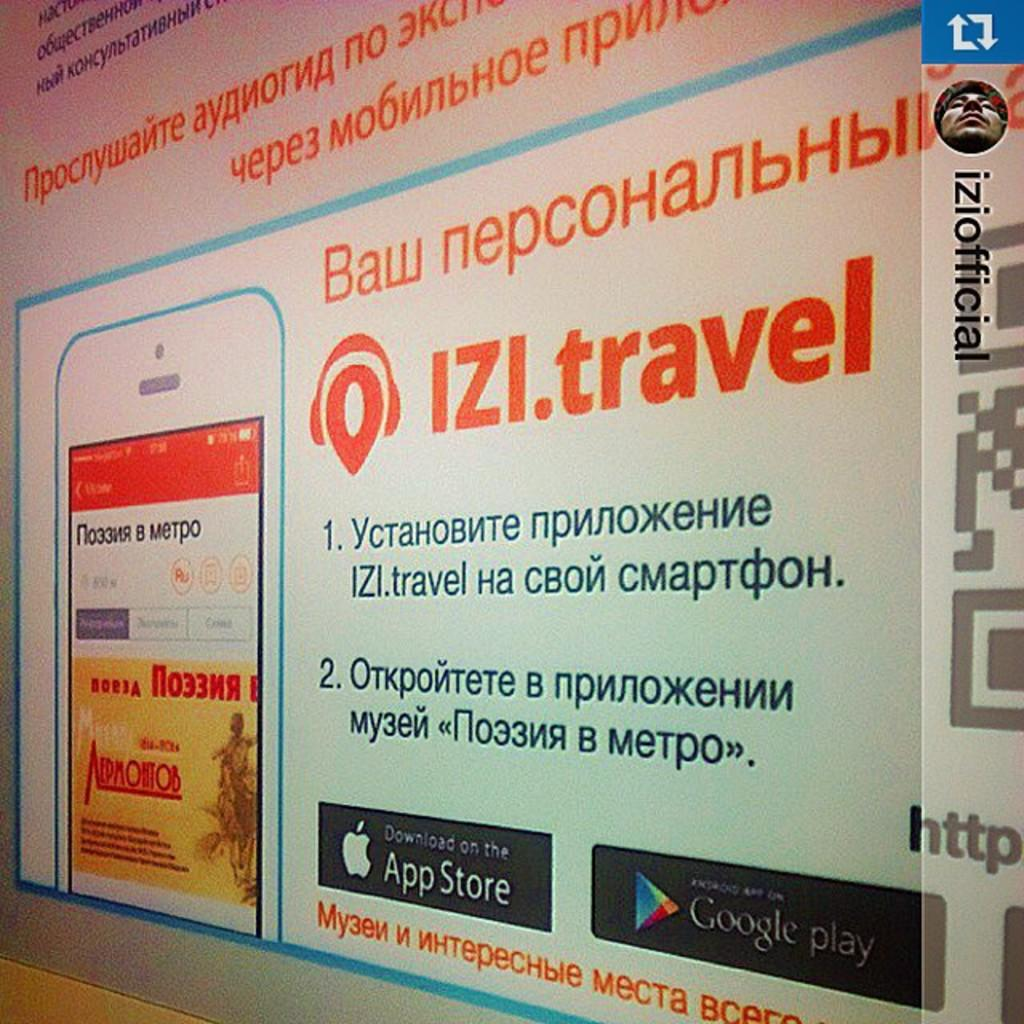<image>
Present a compact description of the photo's key features. An app in a foreign language can be downloaded on the App Store and on Google play. 